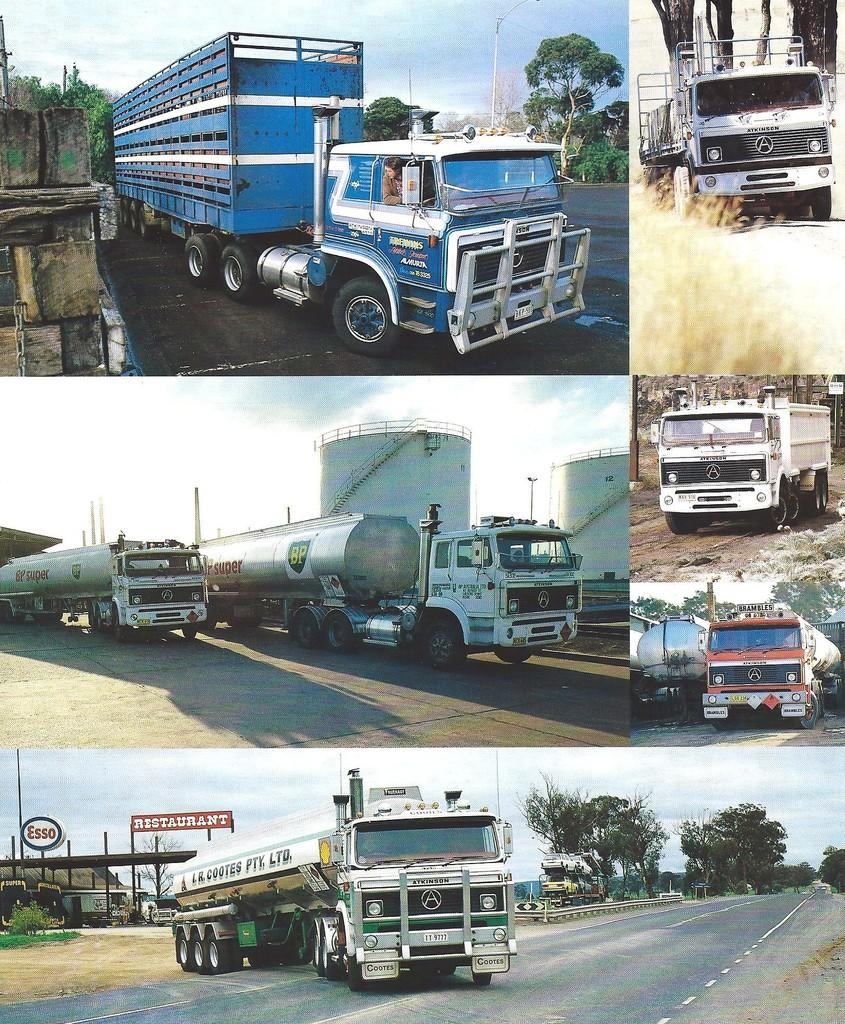What is the main subject of the collage in the image? The collage contains five images, and in each image, there is a truck on the road. What can be seen in the background of the images? There are trees in the background of the images. What is visible at the top of the images? The sky is visible at the top of the images. How many tickets are visible in the image? There are no tickets present in the image; it features a collage of five images with trucks on the road. What type of belief is depicted in the image? There is no belief depicted in the image; it features a collage of five images with trucks on the road. 